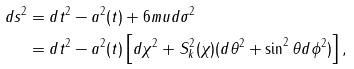<formula> <loc_0><loc_0><loc_500><loc_500>d s ^ { 2 } & = d t ^ { 2 } - a ^ { 2 } ( t ) + 6 m u d \sigma ^ { 2 } \\ & = d t ^ { 2 } - a ^ { 2 } ( t ) \left [ d \chi ^ { 2 } + S _ { k } ^ { 2 } ( \chi ) ( d \theta ^ { 2 } + \sin ^ { 2 } \theta d \phi ^ { 2 } ) \right ] ,</formula> 